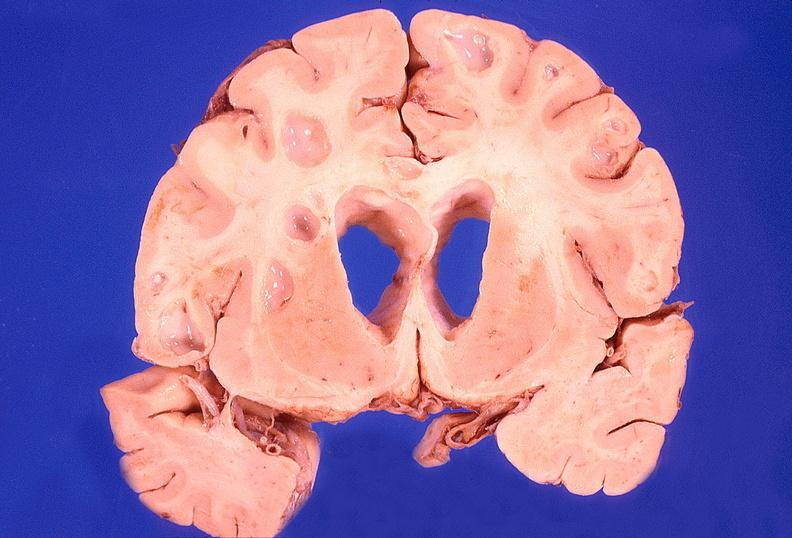does infarct show brain abscess?
Answer the question using a single word or phrase. No 